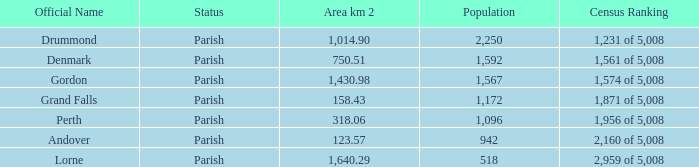51? Denmark. 